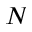<formula> <loc_0><loc_0><loc_500><loc_500>N</formula> 